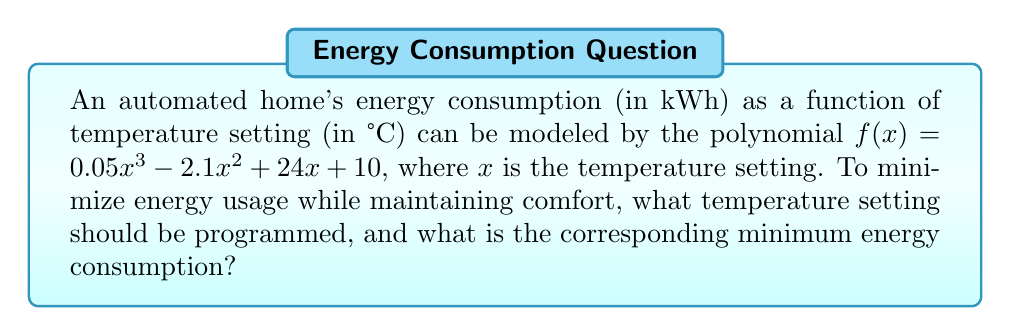Show me your answer to this math problem. To find the minimum point of the polynomial function, we need to follow these steps:

1) First, find the derivative of the function:
   $f'(x) = 0.15x^2 - 4.2x + 24$

2) Set the derivative equal to zero and solve for x:
   $0.15x^2 - 4.2x + 24 = 0$

3) This is a quadratic equation. We can solve it using the quadratic formula:
   $x = \frac{-b \pm \sqrt{b^2 - 4ac}}{2a}$

   Where $a = 0.15$, $b = -4.2$, and $c = 24$

4) Plugging in these values:
   $x = \frac{4.2 \pm \sqrt{(-4.2)^2 - 4(0.15)(24)}}{2(0.15)}$

5) Simplifying:
   $x = \frac{4.2 \pm \sqrt{17.64 - 14.4}}{0.3} = \frac{4.2 \pm \sqrt{3.24}}{0.3} = \frac{4.2 \pm 1.8}{0.3}$

6) This gives us two solutions:
   $x_1 = \frac{4.2 + 1.8}{0.3} = 20$ and $x_2 = \frac{4.2 - 1.8}{0.3} = 8$

7) To determine which of these is the minimum point, we can check the second derivative:
   $f''(x) = 0.3x - 4.2$

8) At $x = 20$: $f''(20) = 0.3(20) - 4.2 = 1.8 > 0$
   This confirms that $x = 20$ is the minimum point.

9) To find the minimum energy consumption, we plug $x = 20$ into the original function:
   $f(20) = 0.05(20)^3 - 2.1(20)^2 + 24(20) + 10$
   $= 400 - 840 + 480 + 10 = 50$

Therefore, the optimal temperature setting is 20°C, resulting in a minimum energy consumption of 50 kWh.
Answer: The optimal temperature setting is 20°C, with a minimum energy consumption of 50 kWh. 